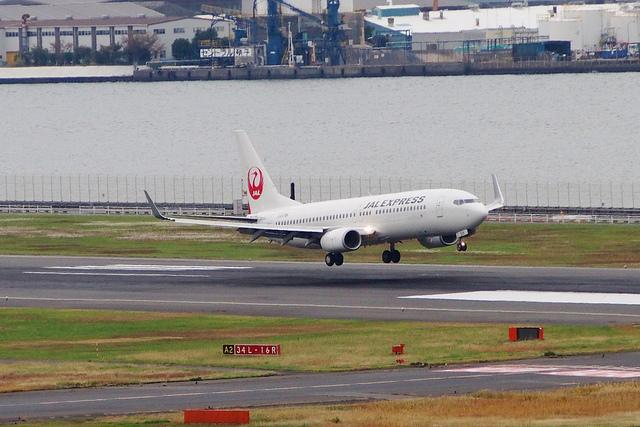In which country is this airport located? Please explain your reasoning. japan. The name on the plane indicates this country 